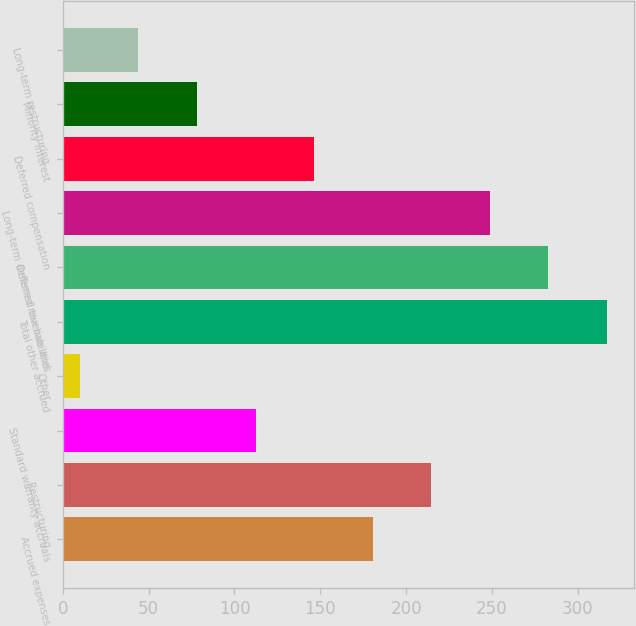Convert chart. <chart><loc_0><loc_0><loc_500><loc_500><bar_chart><fcel>Accrued expenses<fcel>Restructuring<fcel>Standard warranty accruals<fcel>Other<fcel>Total other accrued<fcel>Deferred tax liabilities<fcel>Long-term deferred revenue and<fcel>Deferred compensation<fcel>Minority interest<fcel>Long-term restructuring<nl><fcel>180.5<fcel>214.6<fcel>112.3<fcel>10<fcel>316.9<fcel>282.8<fcel>248.7<fcel>146.4<fcel>78.2<fcel>44.1<nl></chart> 